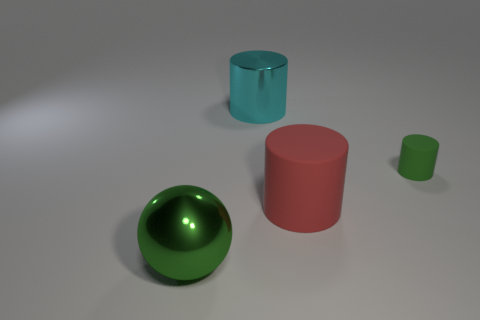Is the size of the metal ball the same as the red cylinder?
Make the answer very short. Yes. What is the size of the green thing that is left of the large metal thing behind the big green object?
Your answer should be compact. Large. What is the shape of the tiny rubber object that is the same color as the large metal ball?
Offer a terse response. Cylinder. What number of cubes are small brown rubber things or large cyan metal things?
Provide a short and direct response. 0. Is the size of the metallic cylinder the same as the green thing that is right of the large metallic ball?
Offer a very short reply. No. Are there more big cyan metallic cylinders in front of the big metallic sphere than small cylinders?
Your answer should be compact. No. There is a sphere that is made of the same material as the cyan cylinder; what is its size?
Keep it short and to the point. Large. Are there any tiny rubber objects that have the same color as the small cylinder?
Keep it short and to the point. No. How many objects are small objects or big things that are behind the red rubber cylinder?
Keep it short and to the point. 2. Is the number of tiny brown rubber cylinders greater than the number of big shiny balls?
Make the answer very short. No. 